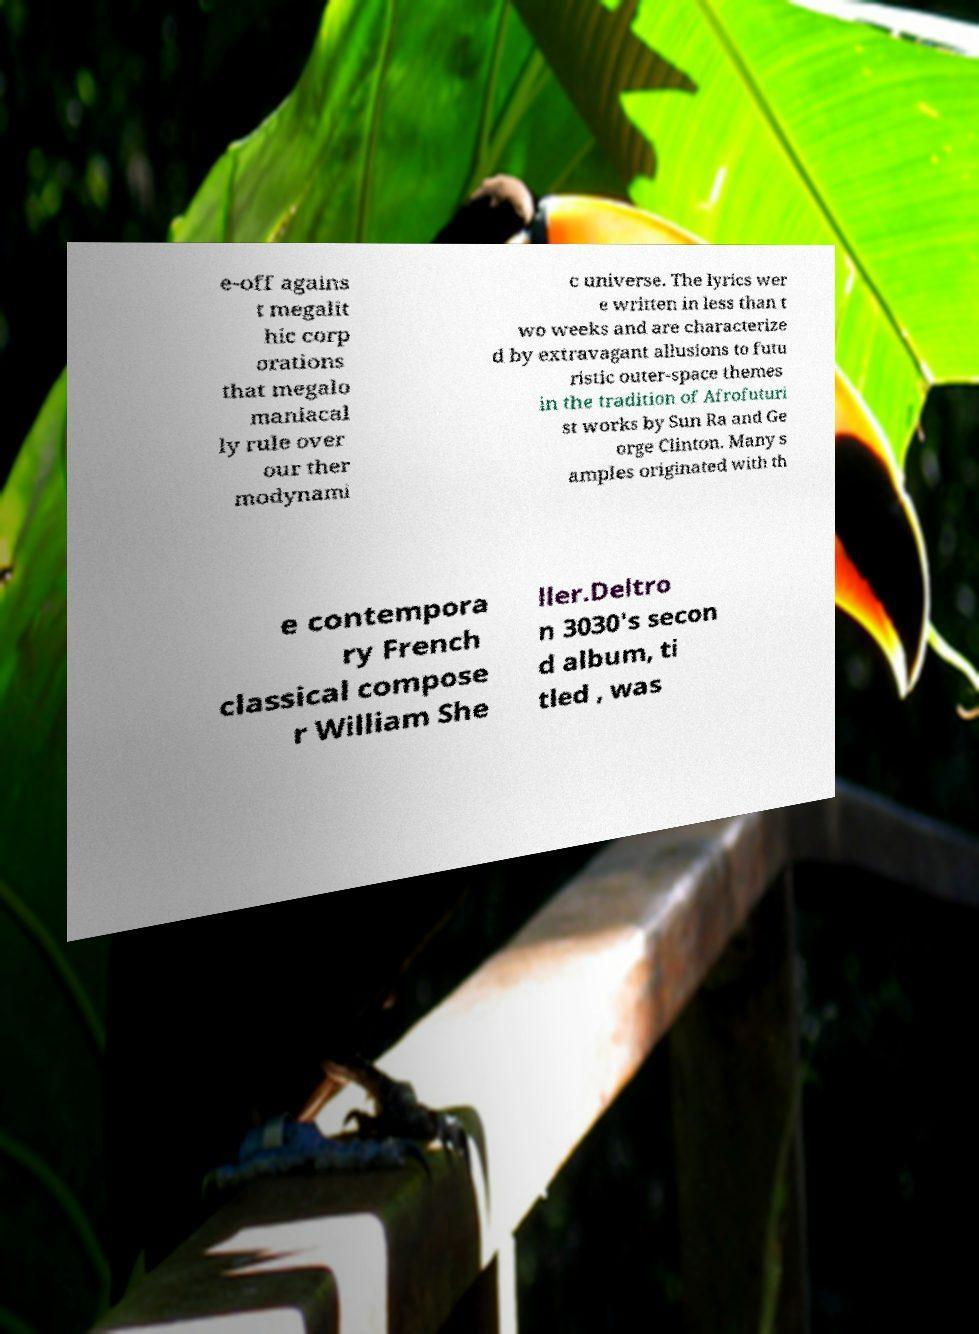Could you extract and type out the text from this image? e-off agains t megalit hic corp orations that megalo maniacal ly rule over our ther modynami c universe. The lyrics wer e written in less than t wo weeks and are characterize d by extravagant allusions to futu ristic outer-space themes in the tradition of Afrofuturi st works by Sun Ra and Ge orge Clinton. Many s amples originated with th e contempora ry French classical compose r William She ller.Deltro n 3030's secon d album, ti tled , was 